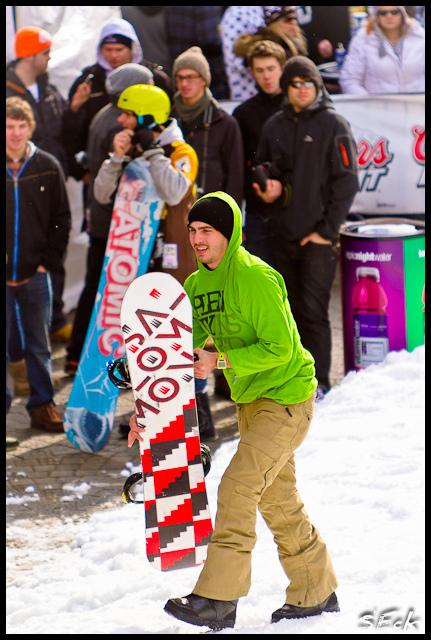What color is the man's sweatshirt?
Write a very short answer. Green. Why are people wearing sunglasses when there is snow on the ground?
Give a very brief answer. Sun. What is the guy holding in his hands?
Keep it brief. Snowboard. 